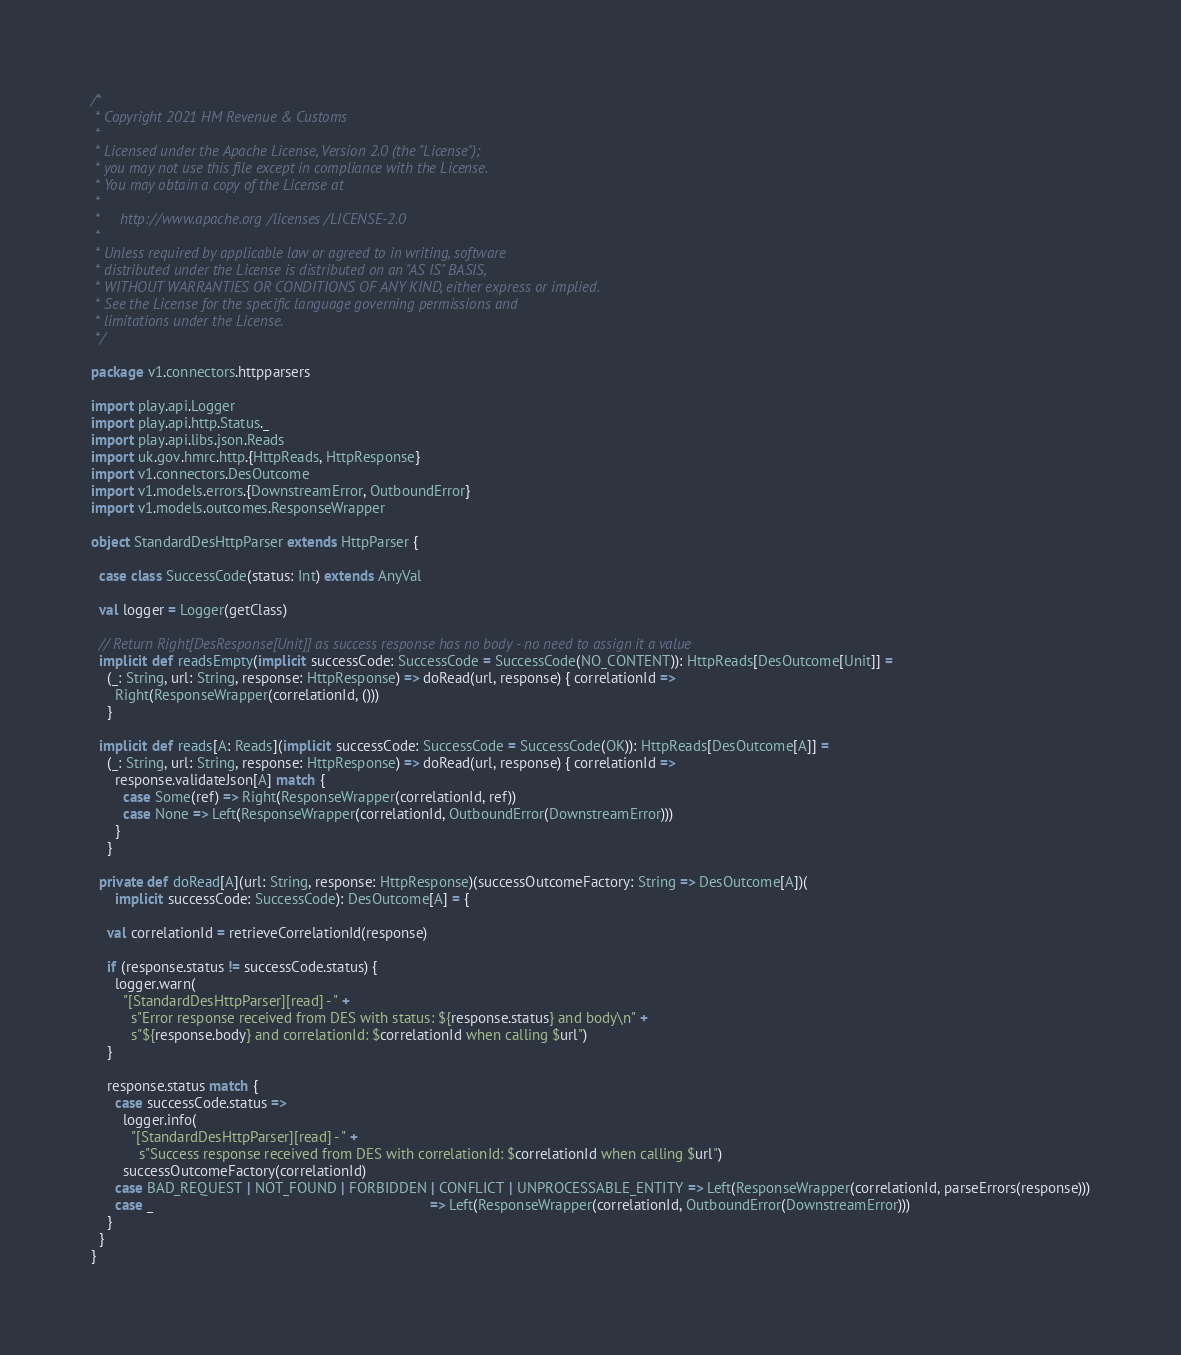Convert code to text. <code><loc_0><loc_0><loc_500><loc_500><_Scala_>/*
 * Copyright 2021 HM Revenue & Customs
 *
 * Licensed under the Apache License, Version 2.0 (the "License");
 * you may not use this file except in compliance with the License.
 * You may obtain a copy of the License at
 *
 *     http://www.apache.org/licenses/LICENSE-2.0
 *
 * Unless required by applicable law or agreed to in writing, software
 * distributed under the License is distributed on an "AS IS" BASIS,
 * WITHOUT WARRANTIES OR CONDITIONS OF ANY KIND, either express or implied.
 * See the License for the specific language governing permissions and
 * limitations under the License.
 */

package v1.connectors.httpparsers

import play.api.Logger
import play.api.http.Status._
import play.api.libs.json.Reads
import uk.gov.hmrc.http.{HttpReads, HttpResponse}
import v1.connectors.DesOutcome
import v1.models.errors.{DownstreamError, OutboundError}
import v1.models.outcomes.ResponseWrapper

object StandardDesHttpParser extends HttpParser {

  case class SuccessCode(status: Int) extends AnyVal

  val logger = Logger(getClass)

  // Return Right[DesResponse[Unit]] as success response has no body - no need to assign it a value
  implicit def readsEmpty(implicit successCode: SuccessCode = SuccessCode(NO_CONTENT)): HttpReads[DesOutcome[Unit]] =
    (_: String, url: String, response: HttpResponse) => doRead(url, response) { correlationId =>
      Right(ResponseWrapper(correlationId, ()))
    }

  implicit def reads[A: Reads](implicit successCode: SuccessCode = SuccessCode(OK)): HttpReads[DesOutcome[A]] =
    (_: String, url: String, response: HttpResponse) => doRead(url, response) { correlationId =>
      response.validateJson[A] match {
        case Some(ref) => Right(ResponseWrapper(correlationId, ref))
        case None => Left(ResponseWrapper(correlationId, OutboundError(DownstreamError)))
      }
    }

  private def doRead[A](url: String, response: HttpResponse)(successOutcomeFactory: String => DesOutcome[A])(
      implicit successCode: SuccessCode): DesOutcome[A] = {

    val correlationId = retrieveCorrelationId(response)

    if (response.status != successCode.status) {
      logger.warn(
        "[StandardDesHttpParser][read] - " +
          s"Error response received from DES with status: ${response.status} and body\n" +
          s"${response.body} and correlationId: $correlationId when calling $url")
    }

    response.status match {
      case successCode.status =>
        logger.info(
          "[StandardDesHttpParser][read] - " +
            s"Success response received from DES with correlationId: $correlationId when calling $url")
        successOutcomeFactory(correlationId)
      case BAD_REQUEST | NOT_FOUND | FORBIDDEN | CONFLICT | UNPROCESSABLE_ENTITY => Left(ResponseWrapper(correlationId, parseErrors(response)))
      case _                                                                     => Left(ResponseWrapper(correlationId, OutboundError(DownstreamError)))
    }
  }
}
</code> 